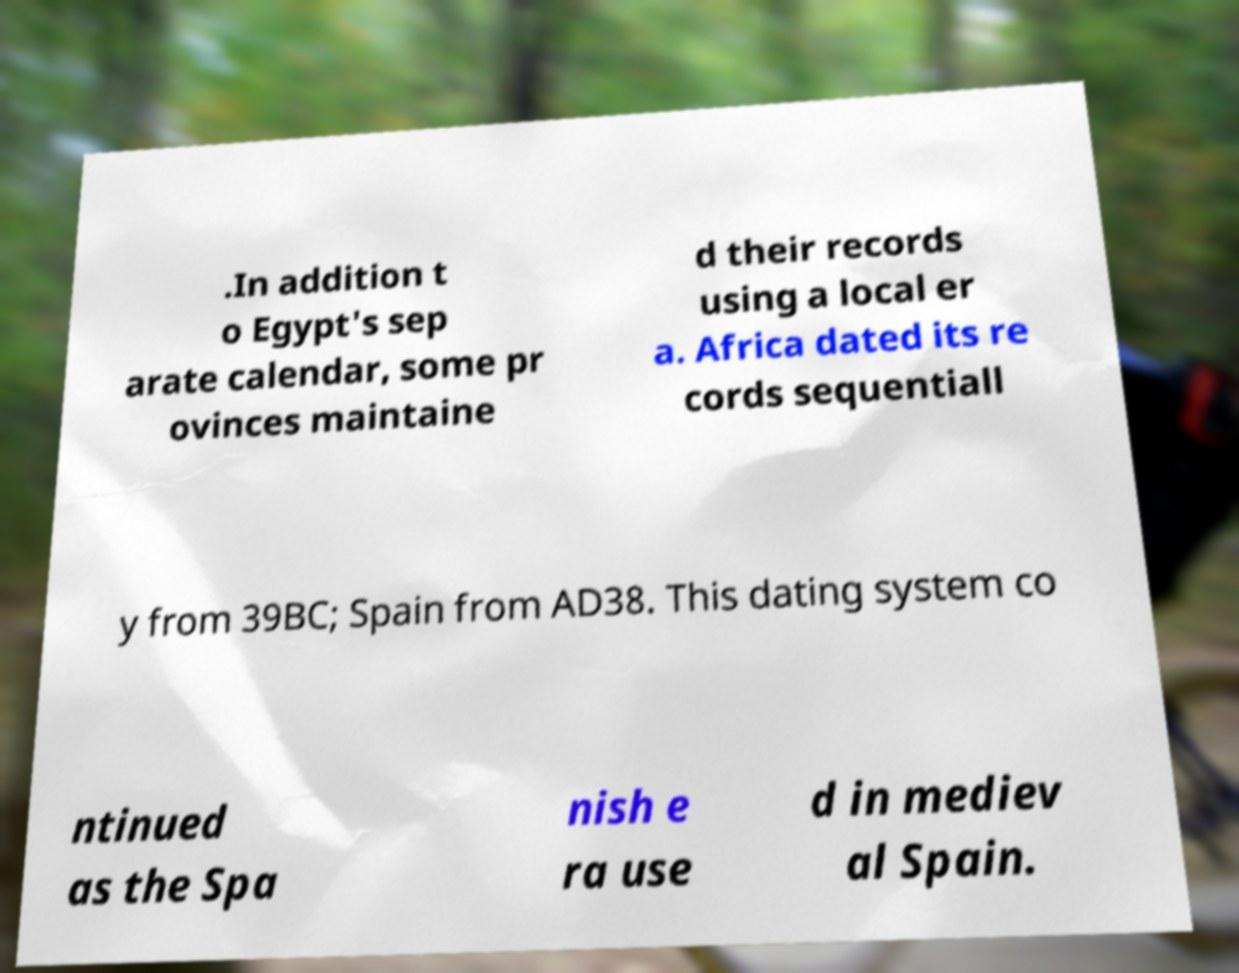There's text embedded in this image that I need extracted. Can you transcribe it verbatim? .In addition t o Egypt's sep arate calendar, some pr ovinces maintaine d their records using a local er a. Africa dated its re cords sequentiall y from 39BC; Spain from AD38. This dating system co ntinued as the Spa nish e ra use d in mediev al Spain. 